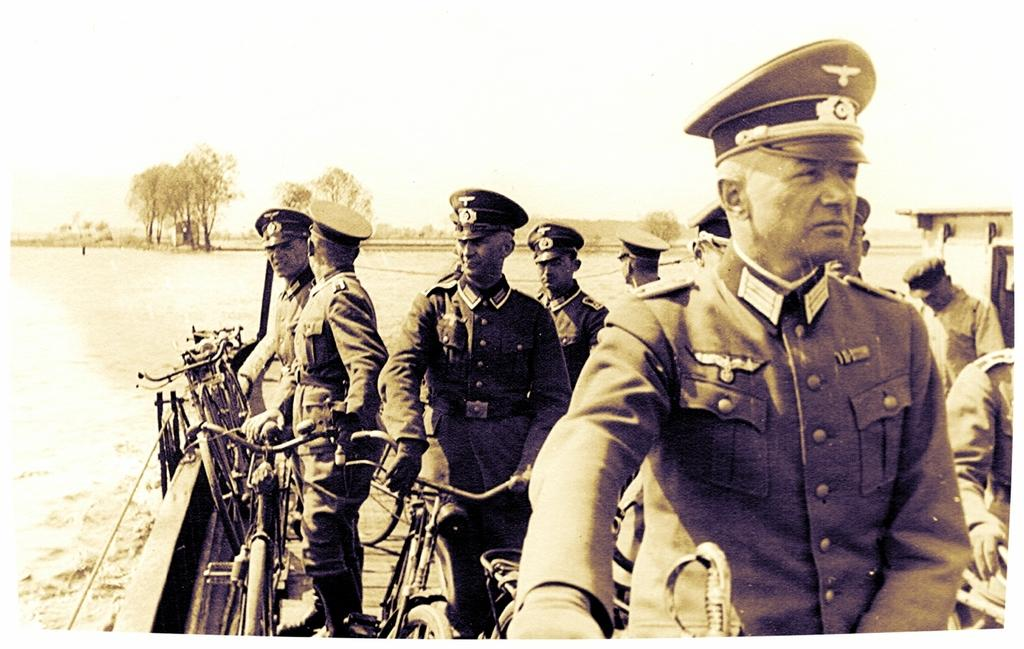What can be seen in the image? There are men in the image. What are the men doing in the image? The men are standing on a wooden surface and holding bicycles. What is visible in the background of the image? There is water, trees, and the sky visible in the background of the image. What type of sack can be seen hanging from the trees in the image? There is no sack present in the image, and no trees are mentioned as having anything hanging from them. How many horses are visible in the image? There are no horses visible in the image; the men are holding bicycles. 